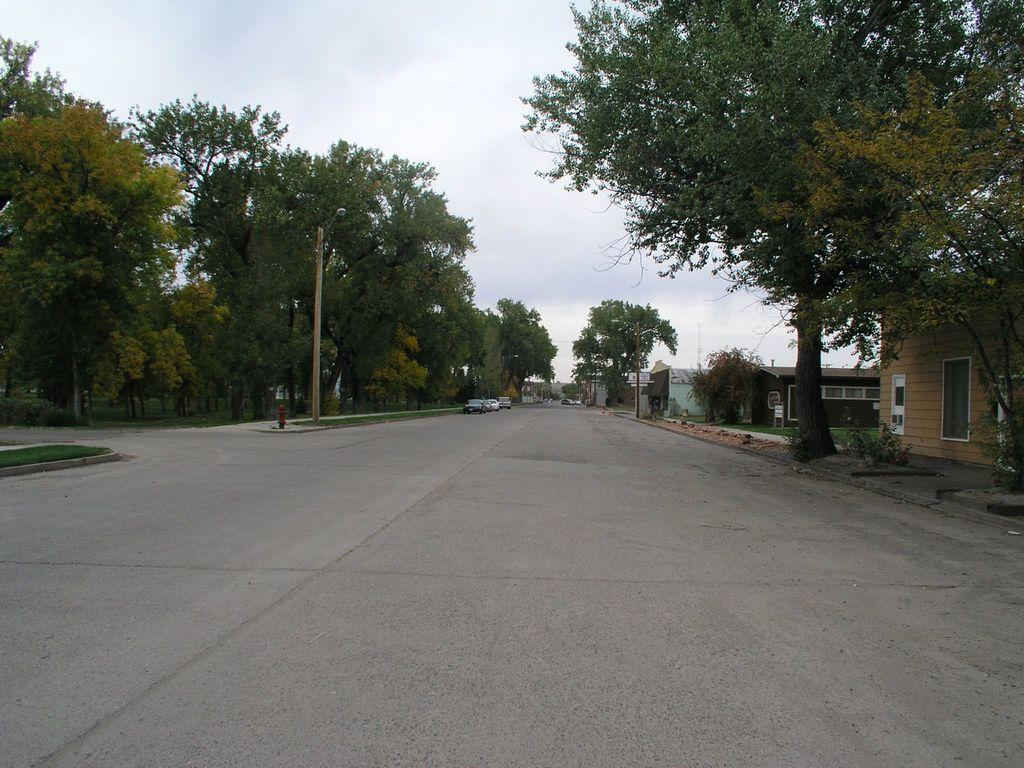What type of vehicles can be seen on the road in the image? There are cars on the road in the image. What structures are present in the image? There are poles, trees, houses, and grass visible in the image. What can be seen in the background of the image? The sky is visible in the background of the image. What type of skirt can be seen floating in the ocean in the image? There is no skirt or ocean present in the image; it features cars on the road, poles, trees, houses, grass, and the sky. 